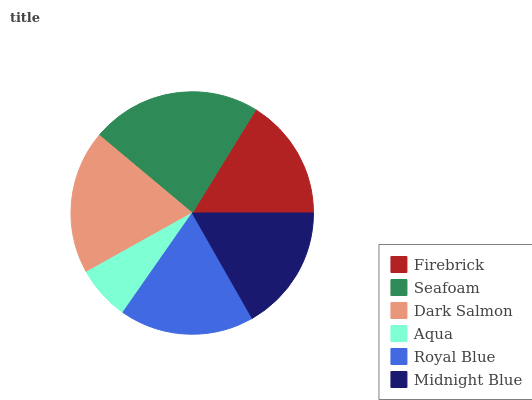Is Aqua the minimum?
Answer yes or no. Yes. Is Seafoam the maximum?
Answer yes or no. Yes. Is Dark Salmon the minimum?
Answer yes or no. No. Is Dark Salmon the maximum?
Answer yes or no. No. Is Seafoam greater than Dark Salmon?
Answer yes or no. Yes. Is Dark Salmon less than Seafoam?
Answer yes or no. Yes. Is Dark Salmon greater than Seafoam?
Answer yes or no. No. Is Seafoam less than Dark Salmon?
Answer yes or no. No. Is Royal Blue the high median?
Answer yes or no. Yes. Is Midnight Blue the low median?
Answer yes or no. Yes. Is Seafoam the high median?
Answer yes or no. No. Is Royal Blue the low median?
Answer yes or no. No. 